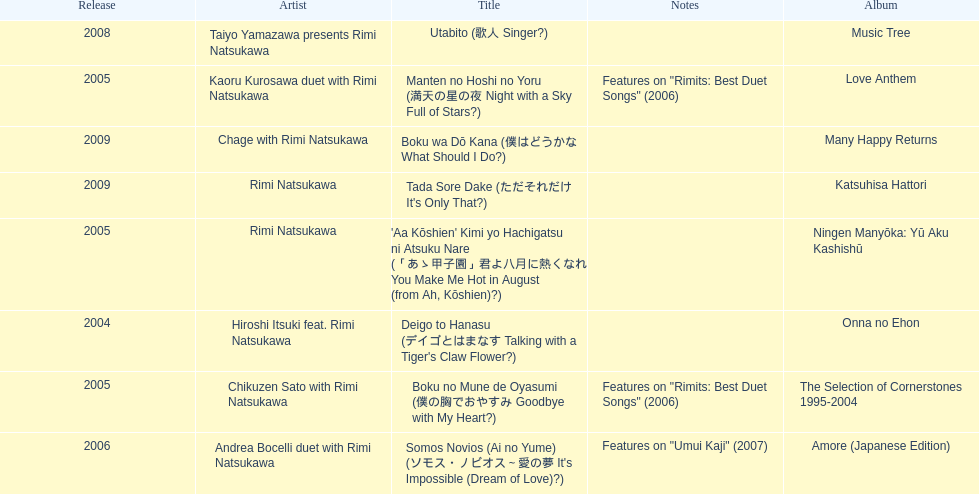What is the number of albums released with the artist rimi natsukawa? 8. 